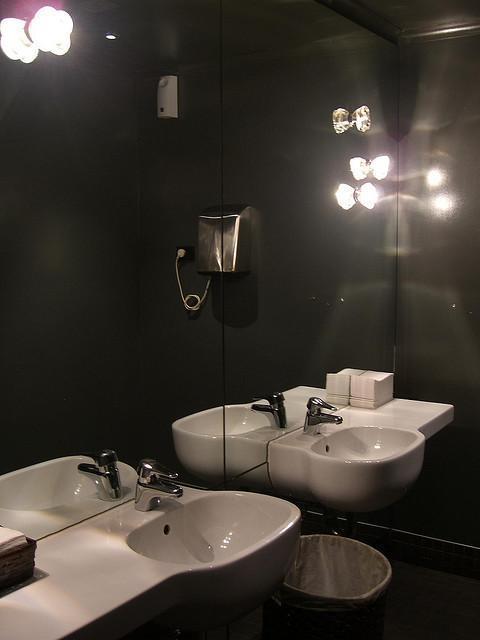How many sinks are in the photo?
Give a very brief answer. 4. 